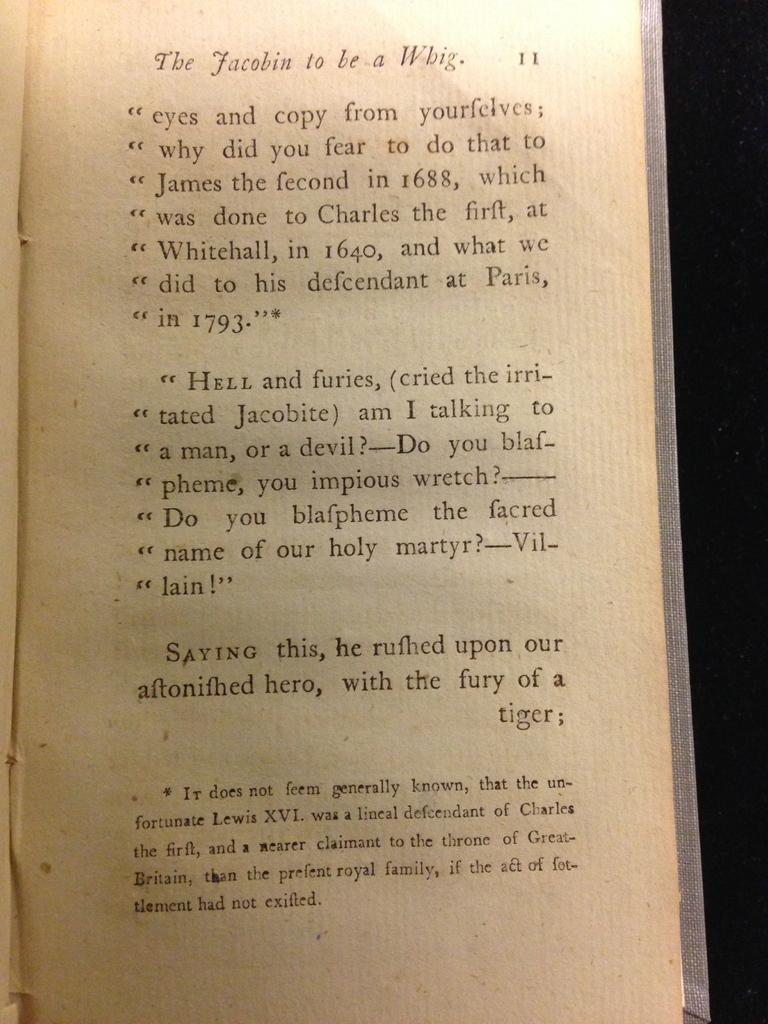Provide a one-sentence caption for the provided image. A page 11 from The Jacobin to be a Whig. 